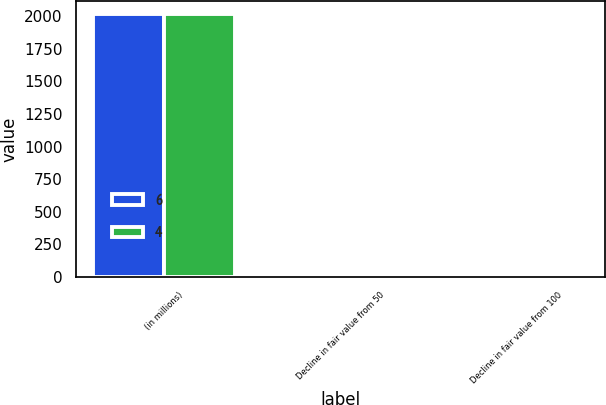Convert chart to OTSL. <chart><loc_0><loc_0><loc_500><loc_500><stacked_bar_chart><ecel><fcel>(in millions)<fcel>Decline in fair value from 50<fcel>Decline in fair value from 100<nl><fcel>6<fcel>2014<fcel>3<fcel>6<nl><fcel>4<fcel>2012<fcel>2<fcel>4<nl></chart> 